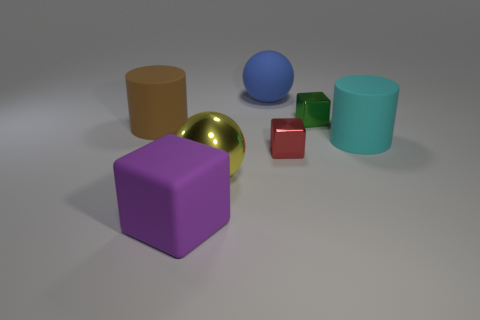The matte thing that is on the right side of the tiny red metallic block has what shape?
Give a very brief answer. Cylinder. What is the shape of the large rubber thing that is on the right side of the yellow thing and in front of the green metal object?
Keep it short and to the point. Cylinder. What number of red things are tiny cylinders or small cubes?
Your answer should be very brief. 1. What is the size of the sphere behind the cylinder that is in front of the brown matte cylinder?
Provide a short and direct response. Large. What is the material of the cyan thing that is the same size as the blue matte object?
Give a very brief answer. Rubber. How many other objects are the same size as the red thing?
Your answer should be compact. 1. What number of cubes are large purple rubber things or cyan things?
Your answer should be very brief. 1. There is a big ball that is left of the big rubber object behind the object on the left side of the matte cube; what is it made of?
Offer a very short reply. Metal. How many yellow spheres have the same material as the tiny green object?
Make the answer very short. 1. Do the cylinder left of the purple matte thing and the red thing have the same size?
Keep it short and to the point. No. 